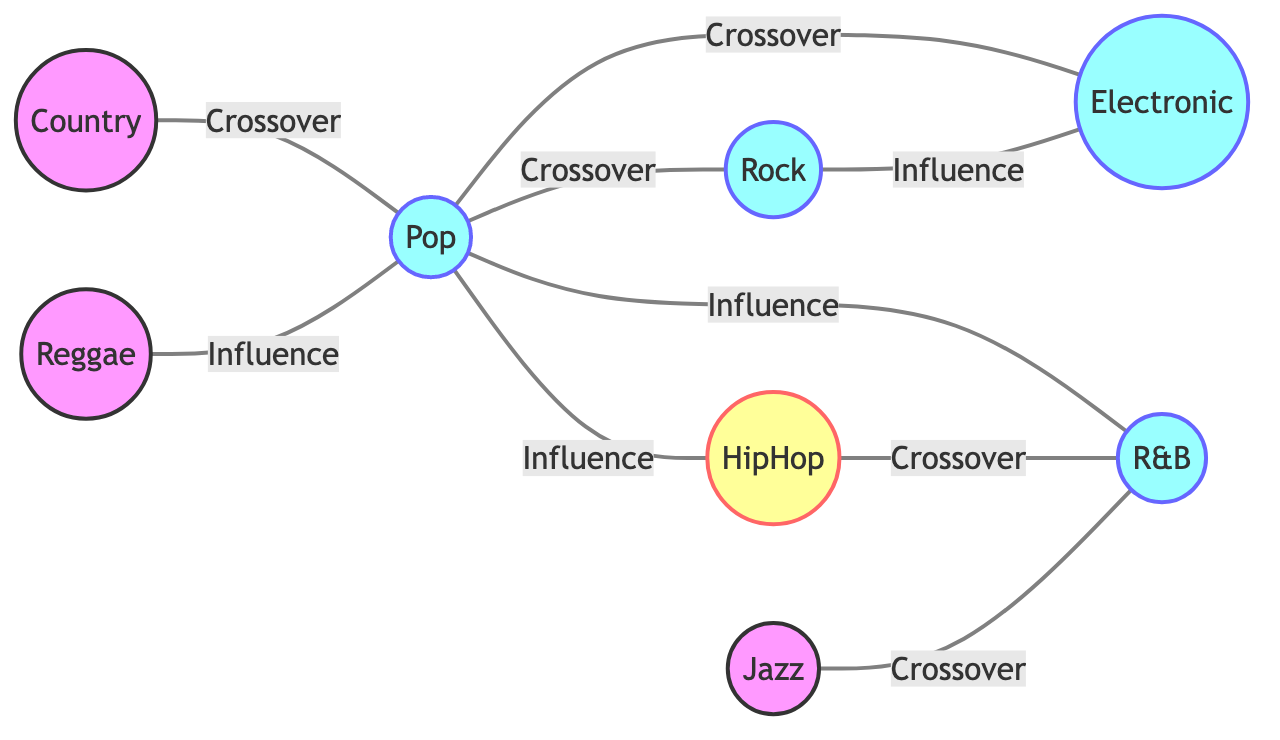What is the total number of nodes in the diagram? The diagram lists eight different musical genres, which are Pop, Rock, HipHop, Electronic, R&B, Country, Reggae, and Jazz. Therefore, the total number of nodes is eight.
Answer: 8 Which genre has the most connections? By examining the edges connecting each node, Pop connects to four other genres: Rock, HipHop, Electronic, and R&B. Thus, it has the most connections.
Answer: Pop What type of relationship exists between HipHop and R&B? There is a crossover relationship between HipHop and R&B as indicated by an edge labeled "Crossover."
Answer: Crossover How many crossover relationships are displayed in the diagram? The diagram contains three edges labeled "Crossover," specifically between Pop and Rock, Pop and Electronic, Country and Pop, and Jazz and R&B. Counting these gives a total of four crossover relationships.
Answer: 4 What is the relationship type between Rock and Electronic? The relationship type between Rock and Electronic is indicated as "Influence" according to the edge connecting them.
Answer: Influence Which genres have a crossover with Pop? The genres that show a crossover relationship with Pop are Rock, Electronic, and Country. These connections are clearly displayed with edges labeled "Crossover."
Answer: Rock, Electronic, Country Are there any genres that only have influence relationships and no crossover? Yes, HipHop has an influence relationship exclusively with Pop and R&B but does not have a crossover relationship with any of the genres. This indicates that it lacks crossover connections while having influence links.
Answer: Yes Which genre influences Reggae? The diagram shows that Pop influences Reggae, as indicated by the edge labeled "Influence" connecting these two genres.
Answer: Pop 